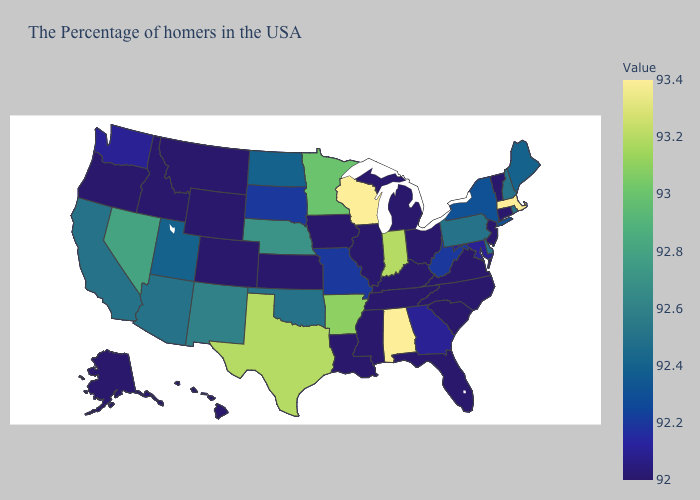Does Florida have the lowest value in the USA?
Write a very short answer. Yes. Among the states that border Missouri , does Illinois have the highest value?
Short answer required. No. Does Alabama have the highest value in the South?
Write a very short answer. Yes. Which states have the lowest value in the USA?
Answer briefly. Vermont, Connecticut, New Jersey, Virginia, North Carolina, South Carolina, Ohio, Florida, Michigan, Kentucky, Tennessee, Illinois, Mississippi, Louisiana, Iowa, Kansas, Wyoming, Colorado, Montana, Idaho, Oregon, Alaska, Hawaii. Which states have the lowest value in the USA?
Be succinct. Vermont, Connecticut, New Jersey, Virginia, North Carolina, South Carolina, Ohio, Florida, Michigan, Kentucky, Tennessee, Illinois, Mississippi, Louisiana, Iowa, Kansas, Wyoming, Colorado, Montana, Idaho, Oregon, Alaska, Hawaii. Does Florida have a lower value than North Dakota?
Concise answer only. Yes. Among the states that border New Mexico , does Texas have the highest value?
Be succinct. Yes. 